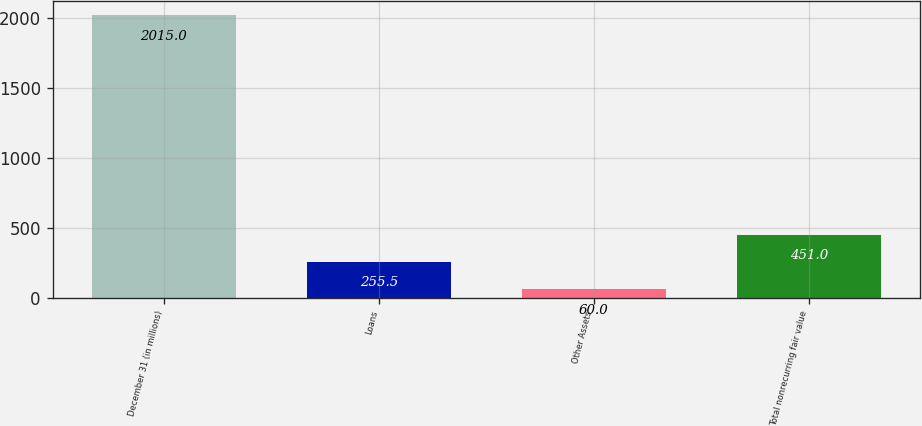Convert chart to OTSL. <chart><loc_0><loc_0><loc_500><loc_500><bar_chart><fcel>December 31 (in millions)<fcel>Loans<fcel>Other Assets<fcel>Total nonrecurring fair value<nl><fcel>2015<fcel>255.5<fcel>60<fcel>451<nl></chart> 